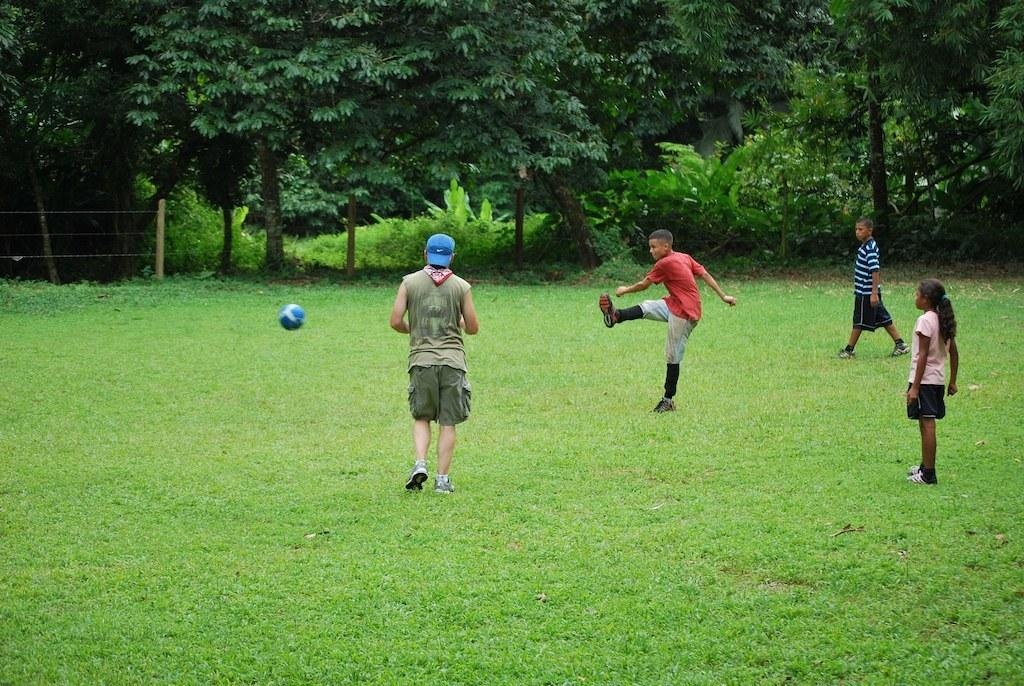How many people are present in the image? There are four persons standing on the ground. Can you describe the clothing of one of the persons? One person is wearing a blue cap. What can be seen in the background of the image? There is a ball and a group of trees in the background. What position does the train conductor hold in the image? There is no train or conductor present in the image. How many fingers does the person with the blue cap have? The number of fingers a person has cannot be determined from the image alone, as it does not show the person's hands. 